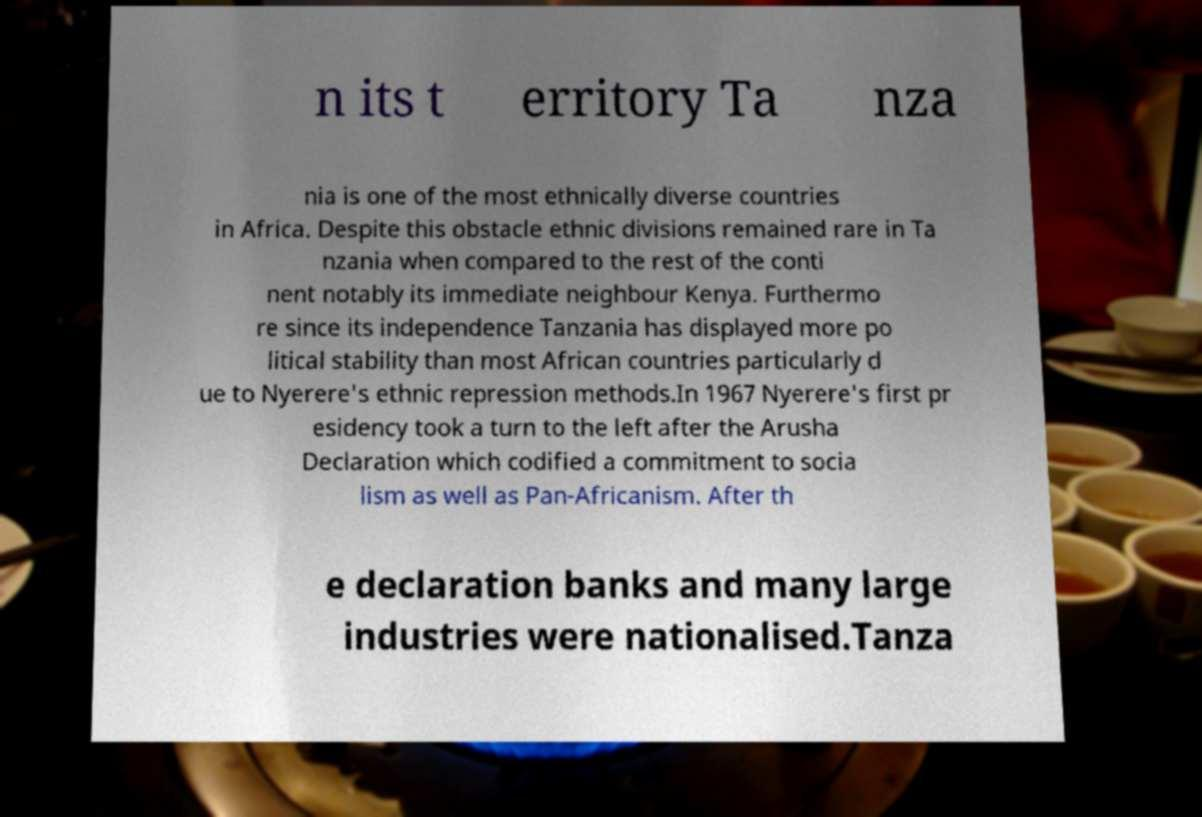Can you accurately transcribe the text from the provided image for me? n its t erritory Ta nza nia is one of the most ethnically diverse countries in Africa. Despite this obstacle ethnic divisions remained rare in Ta nzania when compared to the rest of the conti nent notably its immediate neighbour Kenya. Furthermo re since its independence Tanzania has displayed more po litical stability than most African countries particularly d ue to Nyerere's ethnic repression methods.In 1967 Nyerere's first pr esidency took a turn to the left after the Arusha Declaration which codified a commitment to socia lism as well as Pan-Africanism. After th e declaration banks and many large industries were nationalised.Tanza 